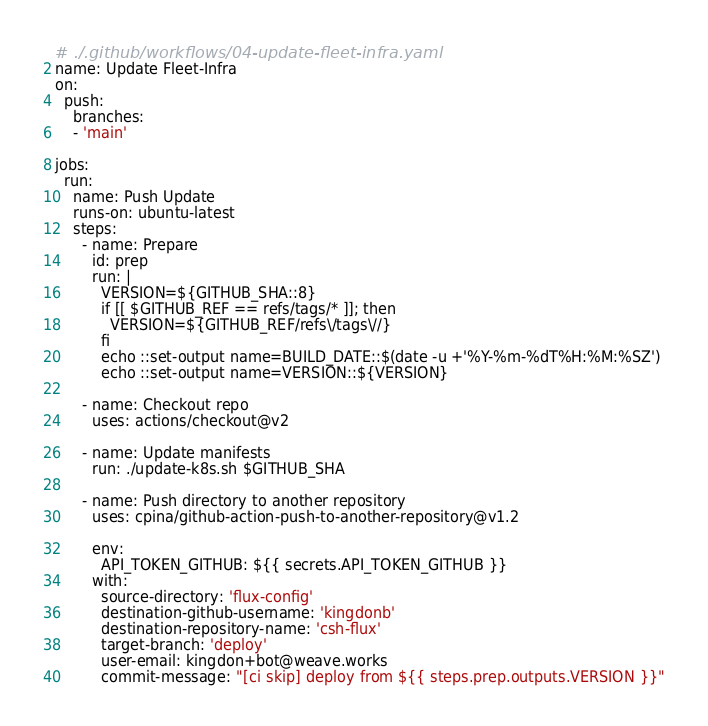Convert code to text. <code><loc_0><loc_0><loc_500><loc_500><_YAML_># ./.github/workflows/04-update-fleet-infra.yaml
name: Update Fleet-Infra
on:
  push:
    branches:
    - 'main'

jobs:
  run:
    name: Push Update
    runs-on: ubuntu-latest
    steps:
      - name: Prepare
        id: prep
        run: |
          VERSION=${GITHUB_SHA::8}
          if [[ $GITHUB_REF == refs/tags/* ]]; then
            VERSION=${GITHUB_REF/refs\/tags\//}
          fi
          echo ::set-output name=BUILD_DATE::$(date -u +'%Y-%m-%dT%H:%M:%SZ')
          echo ::set-output name=VERSION::${VERSION}

      - name: Checkout repo
        uses: actions/checkout@v2

      - name: Update manifests
        run: ./update-k8s.sh $GITHUB_SHA

      - name: Push directory to another repository
        uses: cpina/github-action-push-to-another-repository@v1.2

        env:
          API_TOKEN_GITHUB: ${{ secrets.API_TOKEN_GITHUB }}
        with:
          source-directory: 'flux-config'
          destination-github-username: 'kingdonb'
          destination-repository-name: 'csh-flux'
          target-branch: 'deploy'
          user-email: kingdon+bot@weave.works
          commit-message: "[ci skip] deploy from ${{ steps.prep.outputs.VERSION }}"
</code> 